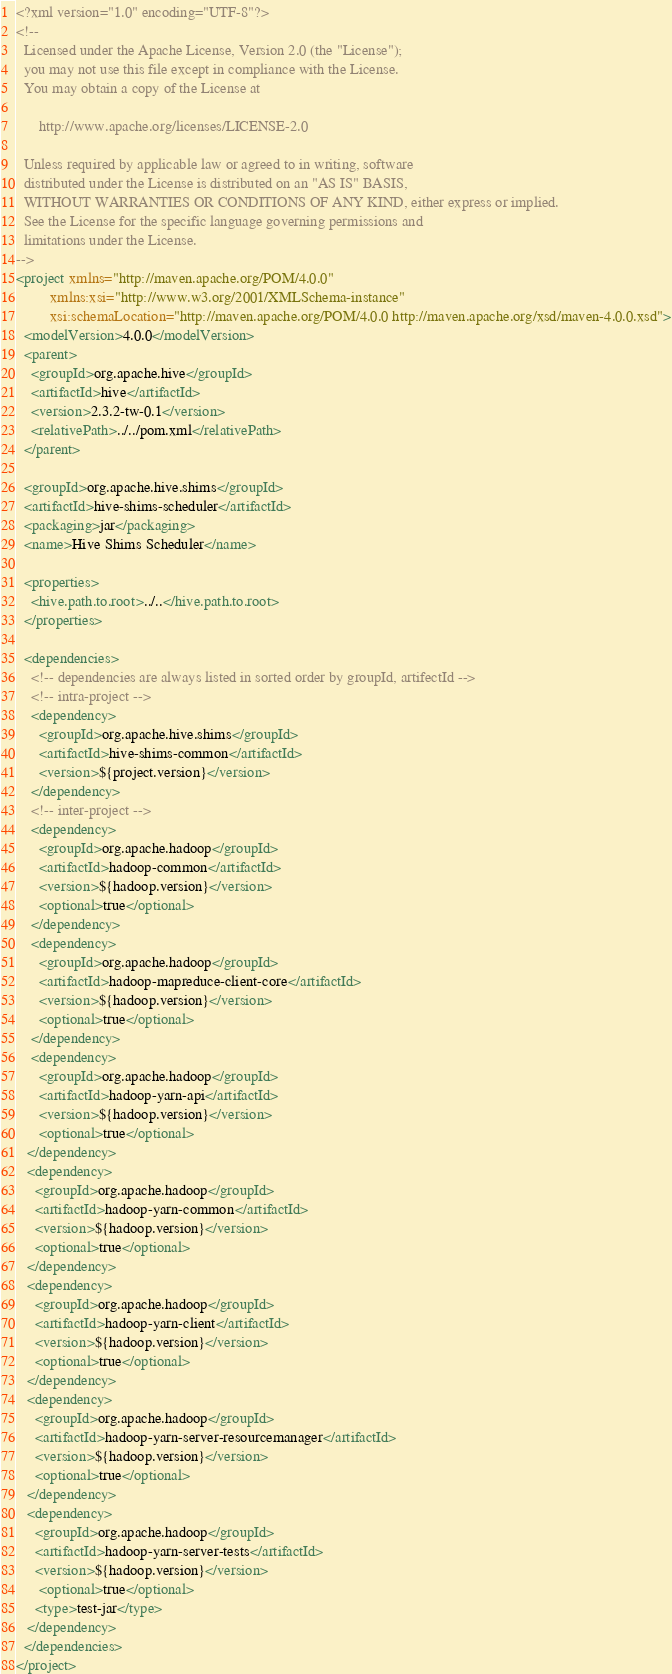Convert code to text. <code><loc_0><loc_0><loc_500><loc_500><_XML_><?xml version="1.0" encoding="UTF-8"?>
<!--
  Licensed under the Apache License, Version 2.0 (the "License");
  you may not use this file except in compliance with the License.
  You may obtain a copy of the License at

      http://www.apache.org/licenses/LICENSE-2.0

  Unless required by applicable law or agreed to in writing, software
  distributed under the License is distributed on an "AS IS" BASIS,
  WITHOUT WARRANTIES OR CONDITIONS OF ANY KIND, either express or implied.
  See the License for the specific language governing permissions and
  limitations under the License.
-->
<project xmlns="http://maven.apache.org/POM/4.0.0"
         xmlns:xsi="http://www.w3.org/2001/XMLSchema-instance"
         xsi:schemaLocation="http://maven.apache.org/POM/4.0.0 http://maven.apache.org/xsd/maven-4.0.0.xsd">
  <modelVersion>4.0.0</modelVersion>
  <parent>
    <groupId>org.apache.hive</groupId>
    <artifactId>hive</artifactId>
    <version>2.3.2-tw-0.1</version>
    <relativePath>../../pom.xml</relativePath>
  </parent>

  <groupId>org.apache.hive.shims</groupId>
  <artifactId>hive-shims-scheduler</artifactId>
  <packaging>jar</packaging>
  <name>Hive Shims Scheduler</name>

  <properties>
    <hive.path.to.root>../..</hive.path.to.root>
  </properties>

  <dependencies>
    <!-- dependencies are always listed in sorted order by groupId, artifectId -->
    <!-- intra-project -->
    <dependency>
      <groupId>org.apache.hive.shims</groupId>
      <artifactId>hive-shims-common</artifactId>
      <version>${project.version}</version>
    </dependency>
    <!-- inter-project -->
    <dependency>
      <groupId>org.apache.hadoop</groupId>
      <artifactId>hadoop-common</artifactId>
      <version>${hadoop.version}</version>
      <optional>true</optional>
    </dependency>
    <dependency>
      <groupId>org.apache.hadoop</groupId>
      <artifactId>hadoop-mapreduce-client-core</artifactId>
      <version>${hadoop.version}</version>
      <optional>true</optional>
    </dependency>
    <dependency>
      <groupId>org.apache.hadoop</groupId>
      <artifactId>hadoop-yarn-api</artifactId>
      <version>${hadoop.version}</version>
      <optional>true</optional>
   </dependency>
   <dependency>
     <groupId>org.apache.hadoop</groupId>
     <artifactId>hadoop-yarn-common</artifactId>
     <version>${hadoop.version}</version>
     <optional>true</optional>
   </dependency>
   <dependency>
     <groupId>org.apache.hadoop</groupId>
     <artifactId>hadoop-yarn-client</artifactId>
     <version>${hadoop.version}</version>
     <optional>true</optional>
   </dependency>
   <dependency>
     <groupId>org.apache.hadoop</groupId>
     <artifactId>hadoop-yarn-server-resourcemanager</artifactId>
     <version>${hadoop.version}</version>
     <optional>true</optional>
   </dependency>
   <dependency>
     <groupId>org.apache.hadoop</groupId>
     <artifactId>hadoop-yarn-server-tests</artifactId>
     <version>${hadoop.version}</version>
      <optional>true</optional>
     <type>test-jar</type>
   </dependency>
  </dependencies>
</project>
</code> 